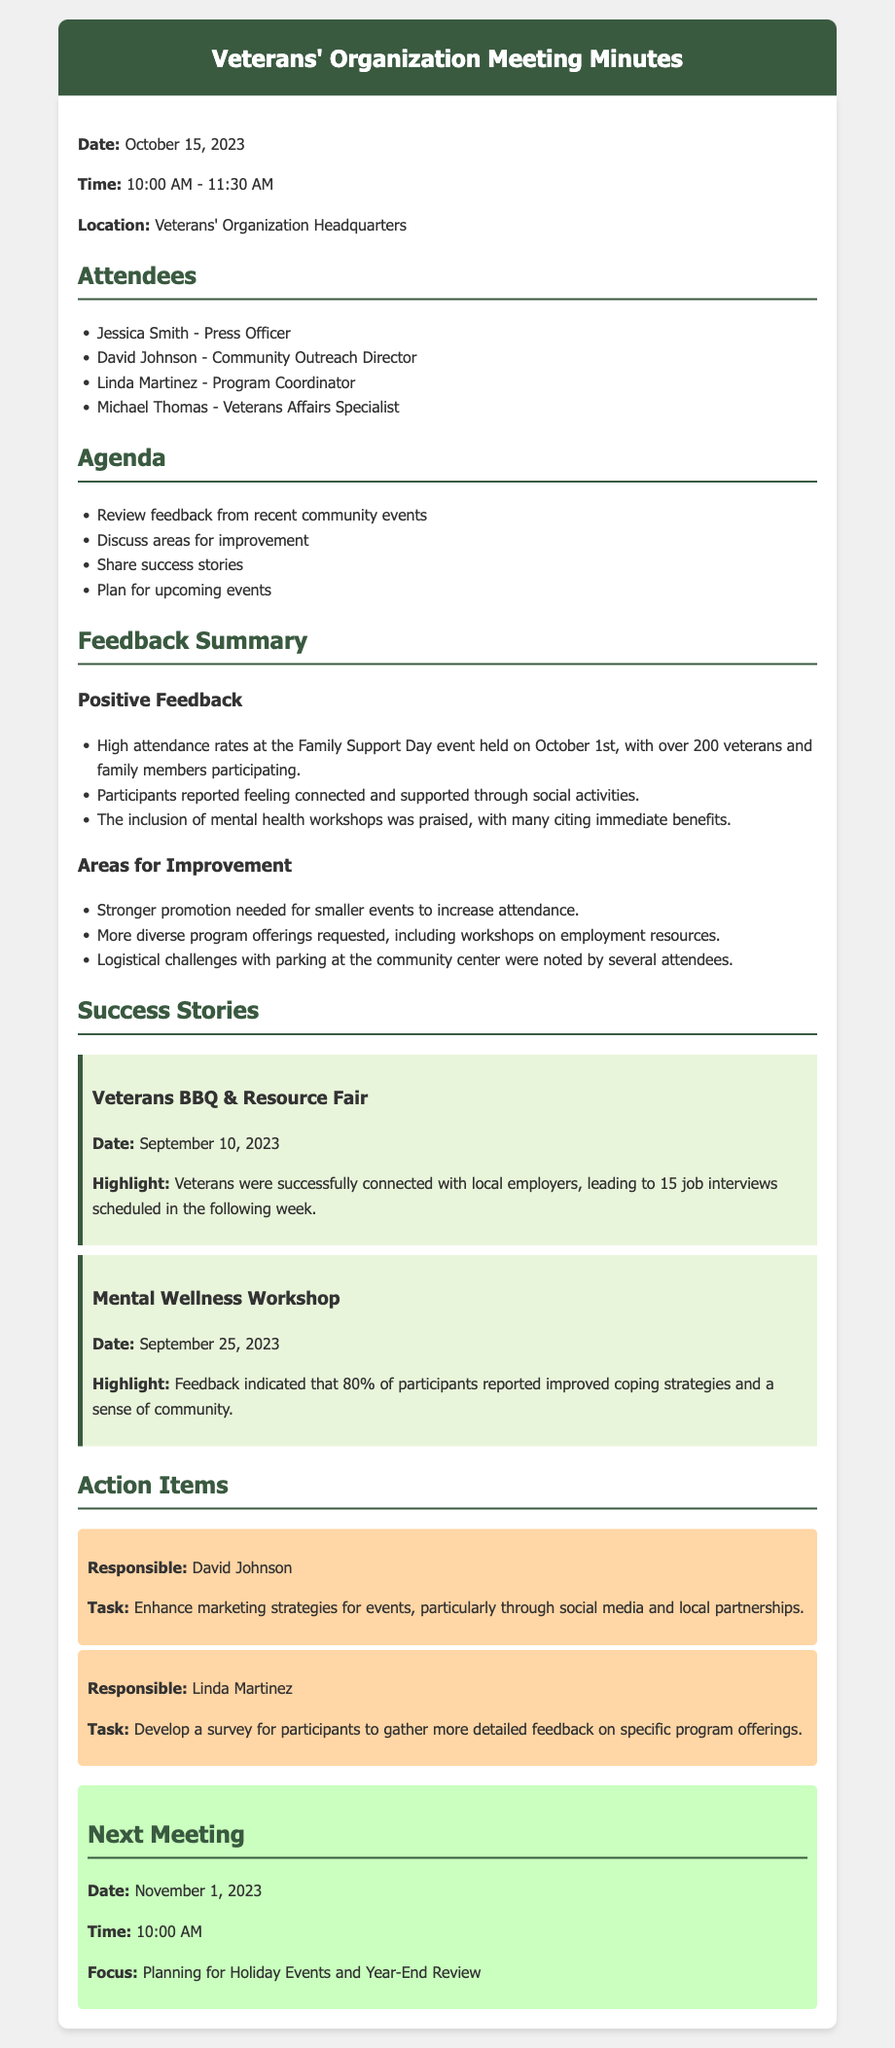what date was the meeting held? The meeting was held on October 15, 2023, as mentioned at the beginning of the document.
Answer: October 15, 2023 who is the Community Outreach Director? The Community Outreach Director listed in the attendees is David Johnson.
Answer: David Johnson how many veterans and family members attended the Family Support Day event? The Family Support Day event had over 200 veterans and family members participating, according to the positive feedback section.
Answer: over 200 what task is David Johnson responsible for? David Johnson is responsible for enhancing marketing strategies for events, as noted in the action items section.
Answer: Enhance marketing strategies for events what percentage of participants reported improved coping strategies in the Mental Wellness Workshop? Feedback indicated that 80% of participants reported improved coping strategies, as outlined in the success stories.
Answer: 80% what was one logistical challenge noted by attendees? Attendees noted logistical challenges with parking at the community center, which is mentioned in the areas for improvement section.
Answer: Parking issues what will the next meeting focus on? The next meeting will focus on planning for Holiday Events and Year-End Review, as stated in the next meeting section.
Answer: Planning for Holiday Events and Year-End Review who is responsible for developing a survey for participants? Linda Martinez is responsible for developing a survey for participants, as specified in the action items.
Answer: Linda Martinez 